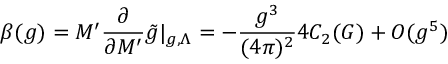<formula> <loc_0><loc_0><loc_500><loc_500>\beta ( g ) = M ^ { \prime } \frac { \partial } { \partial M ^ { \prime } } \tilde { g } | _ { g , \Lambda } = - \frac { g ^ { 3 } } { ( 4 \pi ) ^ { 2 } } 4 C _ { 2 } ( G ) + O ( g ^ { 5 } )</formula> 